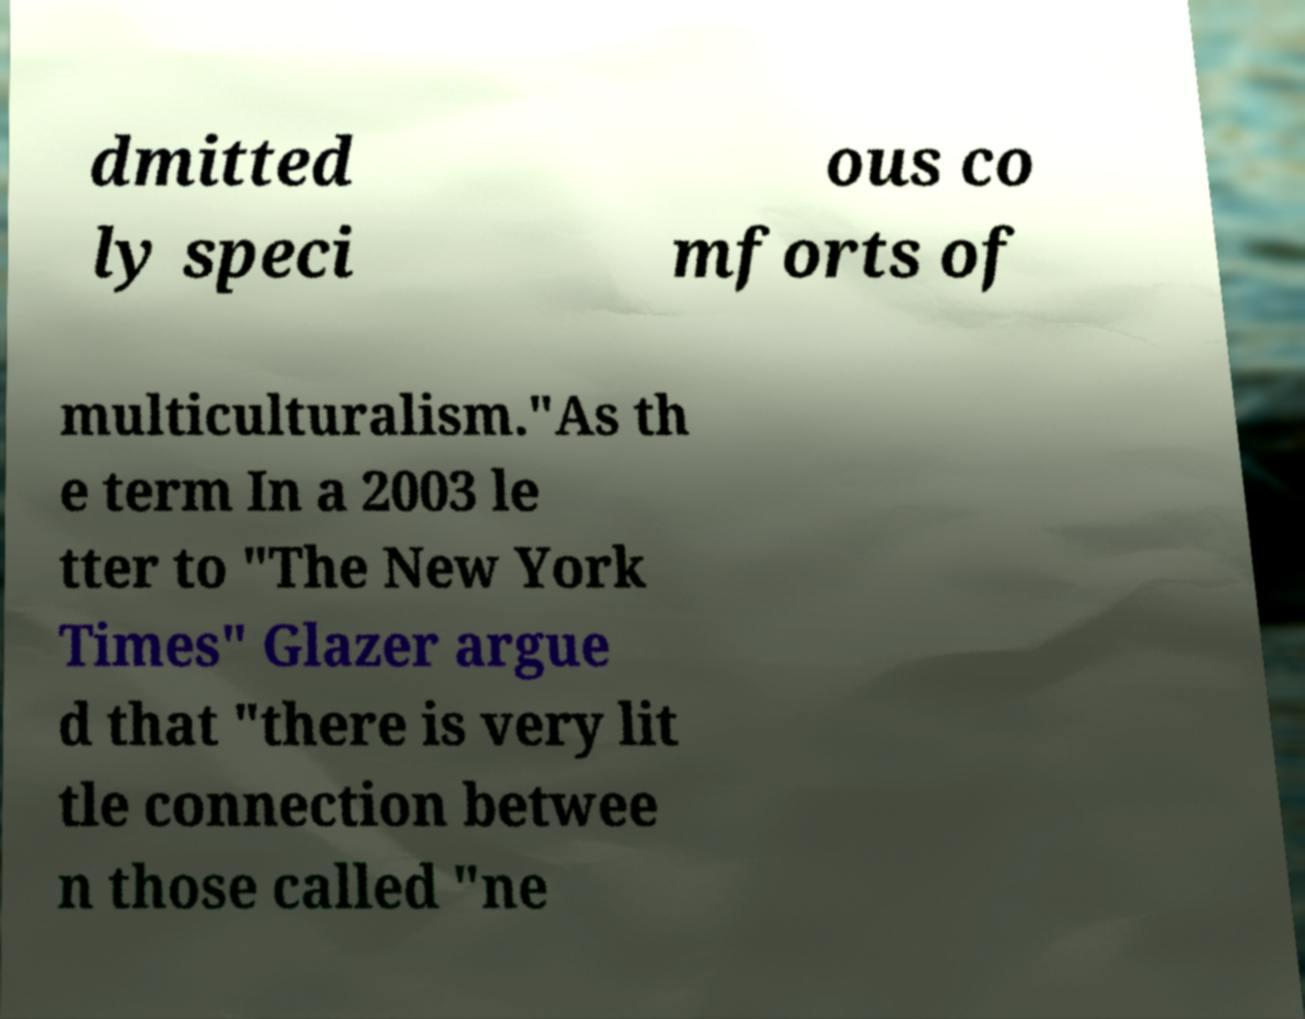Please identify and transcribe the text found in this image. dmitted ly speci ous co mforts of multiculturalism."As th e term In a 2003 le tter to "The New York Times" Glazer argue d that "there is very lit tle connection betwee n those called "ne 